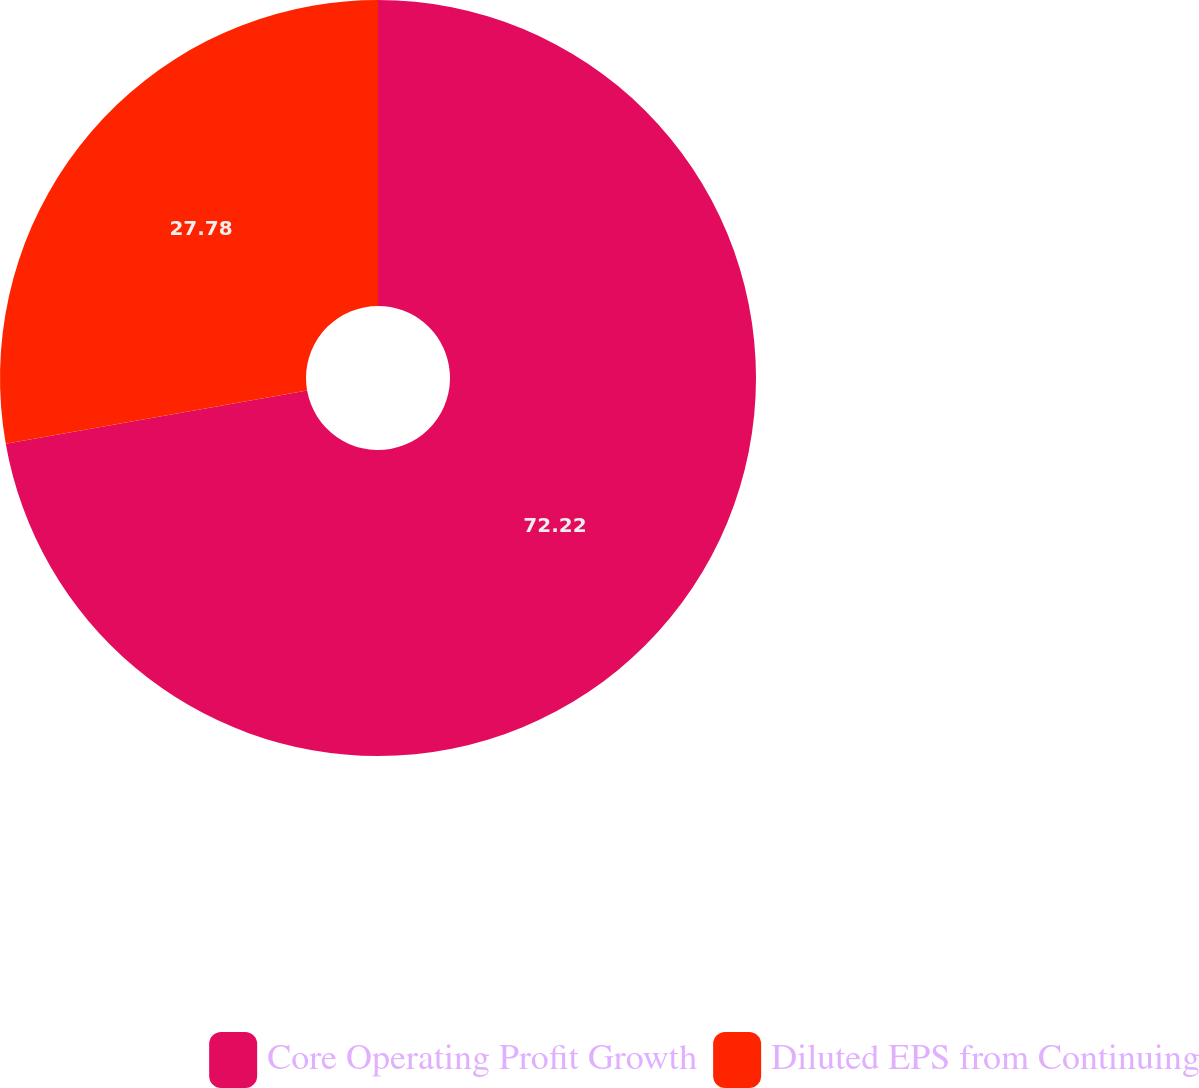Convert chart to OTSL. <chart><loc_0><loc_0><loc_500><loc_500><pie_chart><fcel>Core Operating Profit Growth<fcel>Diluted EPS from Continuing<nl><fcel>72.22%<fcel>27.78%<nl></chart> 